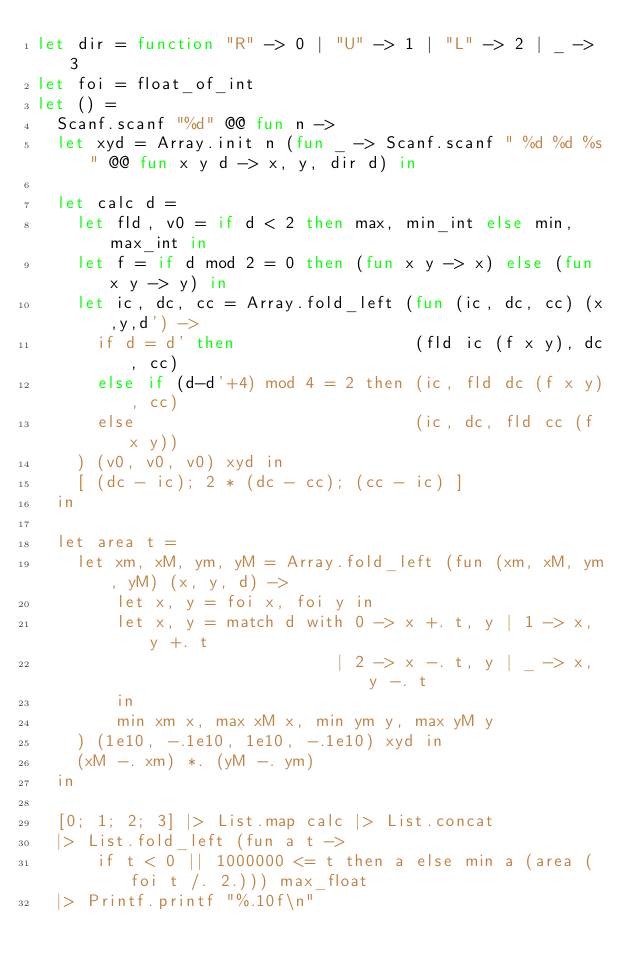Convert code to text. <code><loc_0><loc_0><loc_500><loc_500><_OCaml_>let dir = function "R" -> 0 | "U" -> 1 | "L" -> 2 | _ -> 3
let foi = float_of_int
let () =
  Scanf.scanf "%d" @@ fun n ->
  let xyd = Array.init n (fun _ -> Scanf.scanf " %d %d %s" @@ fun x y d -> x, y, dir d) in

  let calc d =
    let fld, v0 = if d < 2 then max, min_int else min, max_int in
    let f = if d mod 2 = 0 then (fun x y -> x) else (fun x y -> y) in
    let ic, dc, cc = Array.fold_left (fun (ic, dc, cc) (x,y,d') ->
      if d = d' then                  (fld ic (f x y), dc, cc)
      else if (d-d'+4) mod 4 = 2 then (ic, fld dc (f x y), cc)
      else                            (ic, dc, fld cc (f x y))
    ) (v0, v0, v0) xyd in
    [ (dc - ic); 2 * (dc - cc); (cc - ic) ]
  in

  let area t =
    let xm, xM, ym, yM = Array.fold_left (fun (xm, xM, ym, yM) (x, y, d) ->
        let x, y = foi x, foi y in
        let x, y = match d with 0 -> x +. t, y | 1 -> x, y +. t
                              | 2 -> x -. t, y | _ -> x, y -. t
        in
        min xm x, max xM x, min ym y, max yM y
    ) (1e10, -.1e10, 1e10, -.1e10) xyd in
    (xM -. xm) *. (yM -. ym)
  in

  [0; 1; 2; 3] |> List.map calc |> List.concat
  |> List.fold_left (fun a t ->
      if t < 0 || 1000000 <= t then a else min a (area (foi t /. 2.))) max_float
  |> Printf.printf "%.10f\n"
</code> 